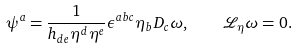Convert formula to latex. <formula><loc_0><loc_0><loc_500><loc_500>\psi ^ { a } = \frac { 1 } { h _ { d e } \eta ^ { d } \eta ^ { e } } \epsilon ^ { a b c } \eta _ { b } D _ { c } \omega , \quad \mathcal { L } _ { \eta } \omega = 0 .</formula> 